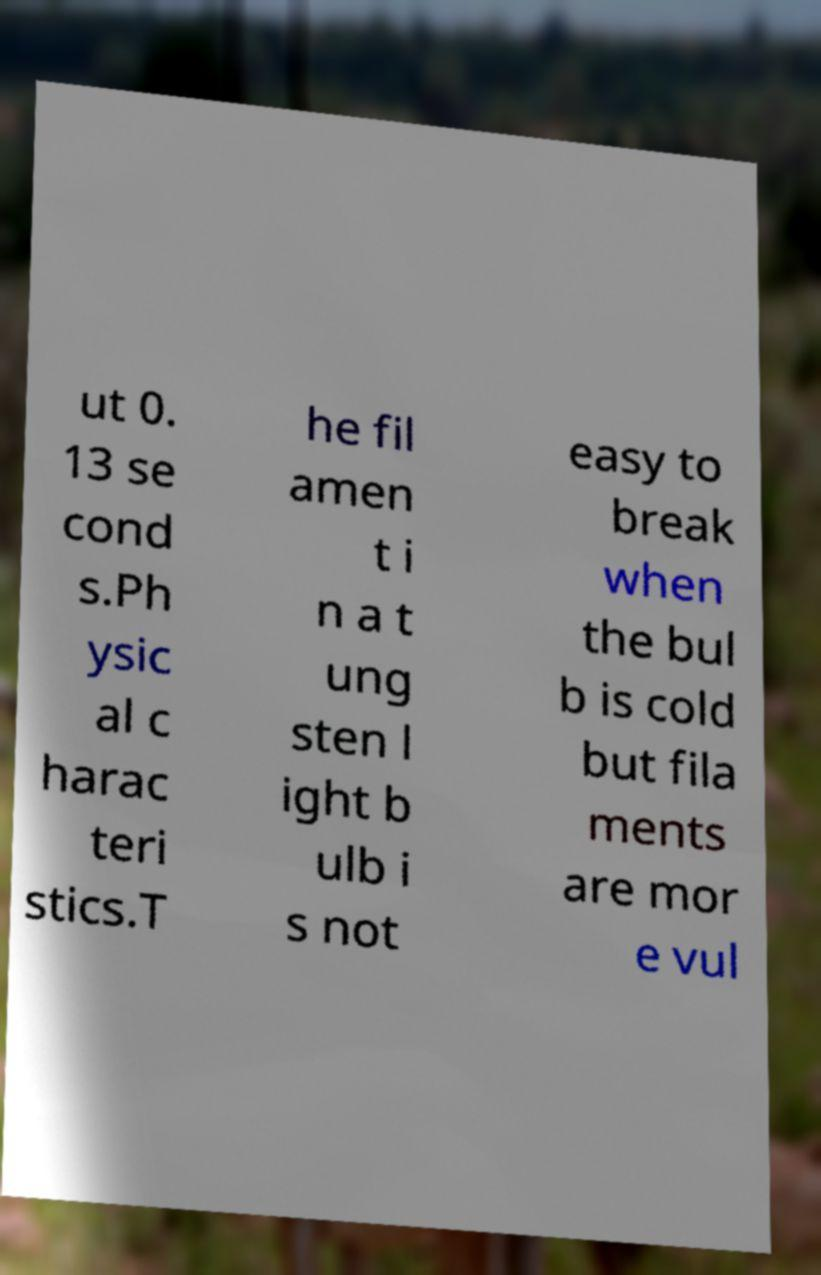What messages or text are displayed in this image? I need them in a readable, typed format. ut 0. 13 se cond s.Ph ysic al c harac teri stics.T he fil amen t i n a t ung sten l ight b ulb i s not easy to break when the bul b is cold but fila ments are mor e vul 